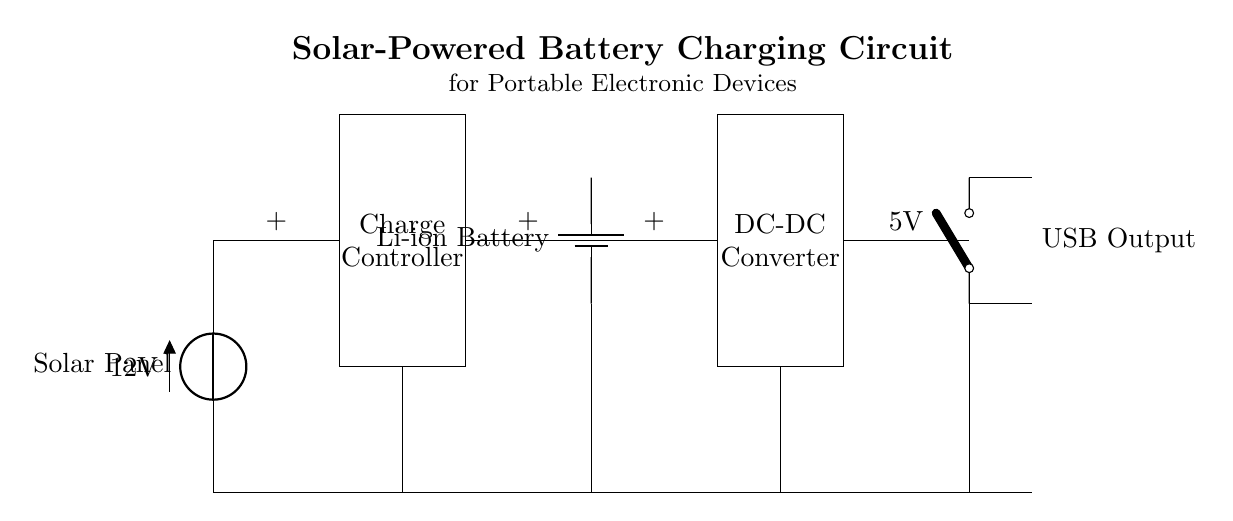What is the voltage produced by the solar panel? The voltage produced by the solar panel is labeled as 12 volts in the circuit diagram. This is indicated by the voltage source connected at the starting point of the circuit.
Answer: 12 volts What type of battery is used in this circuit? The circuit diagram clearly labels the battery as a lithium-ion battery. This information can be found next to the battery component in the circuit.
Answer: Lithium-ion What is the function of the charge controller? The charge controller regulates the voltage and current coming from the solar panel to prevent overcharging and control the power sent to the battery. It is placed directly after the solar panel in the circuit flow.
Answer: Regulates power What is the output voltage for the USB port? The output voltage for the USB port is indicated in the circuit diagram as 5 volts. It follows the connection from the DC-DC converter which steps down the voltage for USB compatibility.
Answer: 5 volts What is the role of the DC-DC converter in this circuit? The DC-DC converter adjusts the voltage output from the lithium-ion battery to a lower voltage suitable for USB devices. This transformer is essential for providing the correct voltage level.
Answer: Voltage adjustment How many main components are in this circuit? There are five main components in this circuit: the solar panel, the charge controller, the lithium-ion battery, the DC-DC converter, and the USB output switch. These components are clearly identifiable in the rendered diagram.
Answer: Five What is the purpose of the open switch in the output? The open switch allows for control over when the USB output is connected, enabling the user to turn the power on or off as needed for efficiency. It serves as a safety feature to prevent unwanted discharge.
Answer: Control power 